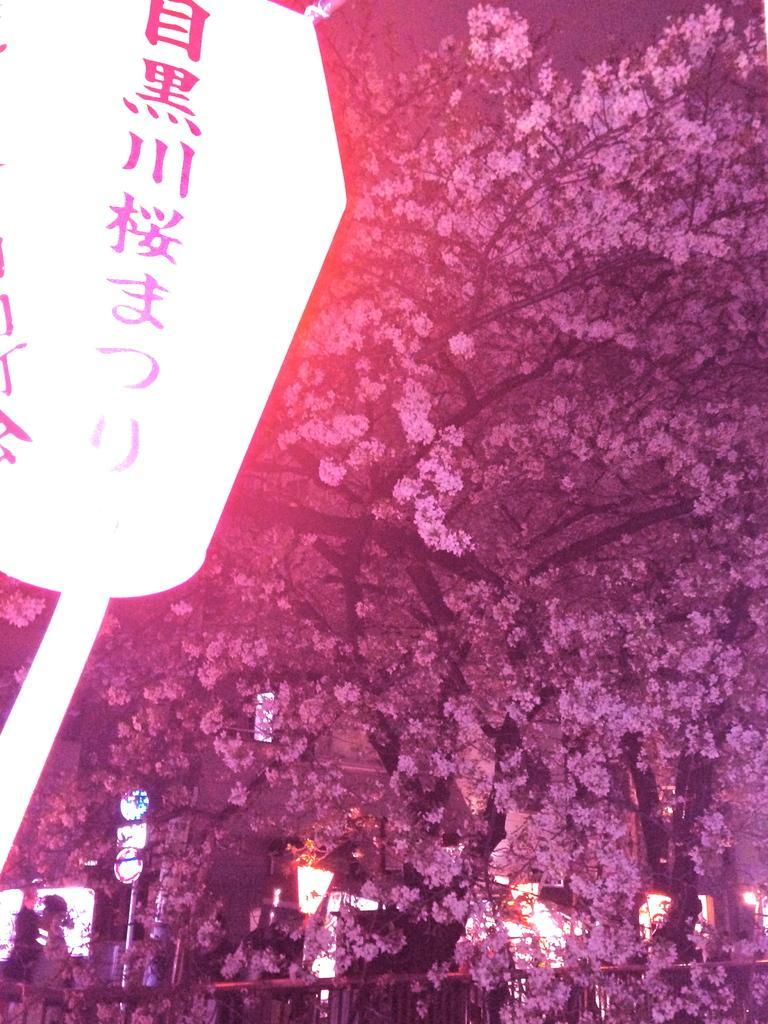Please provide a concise description of this image. In the picture I can see trees, lights and something written on an object. 